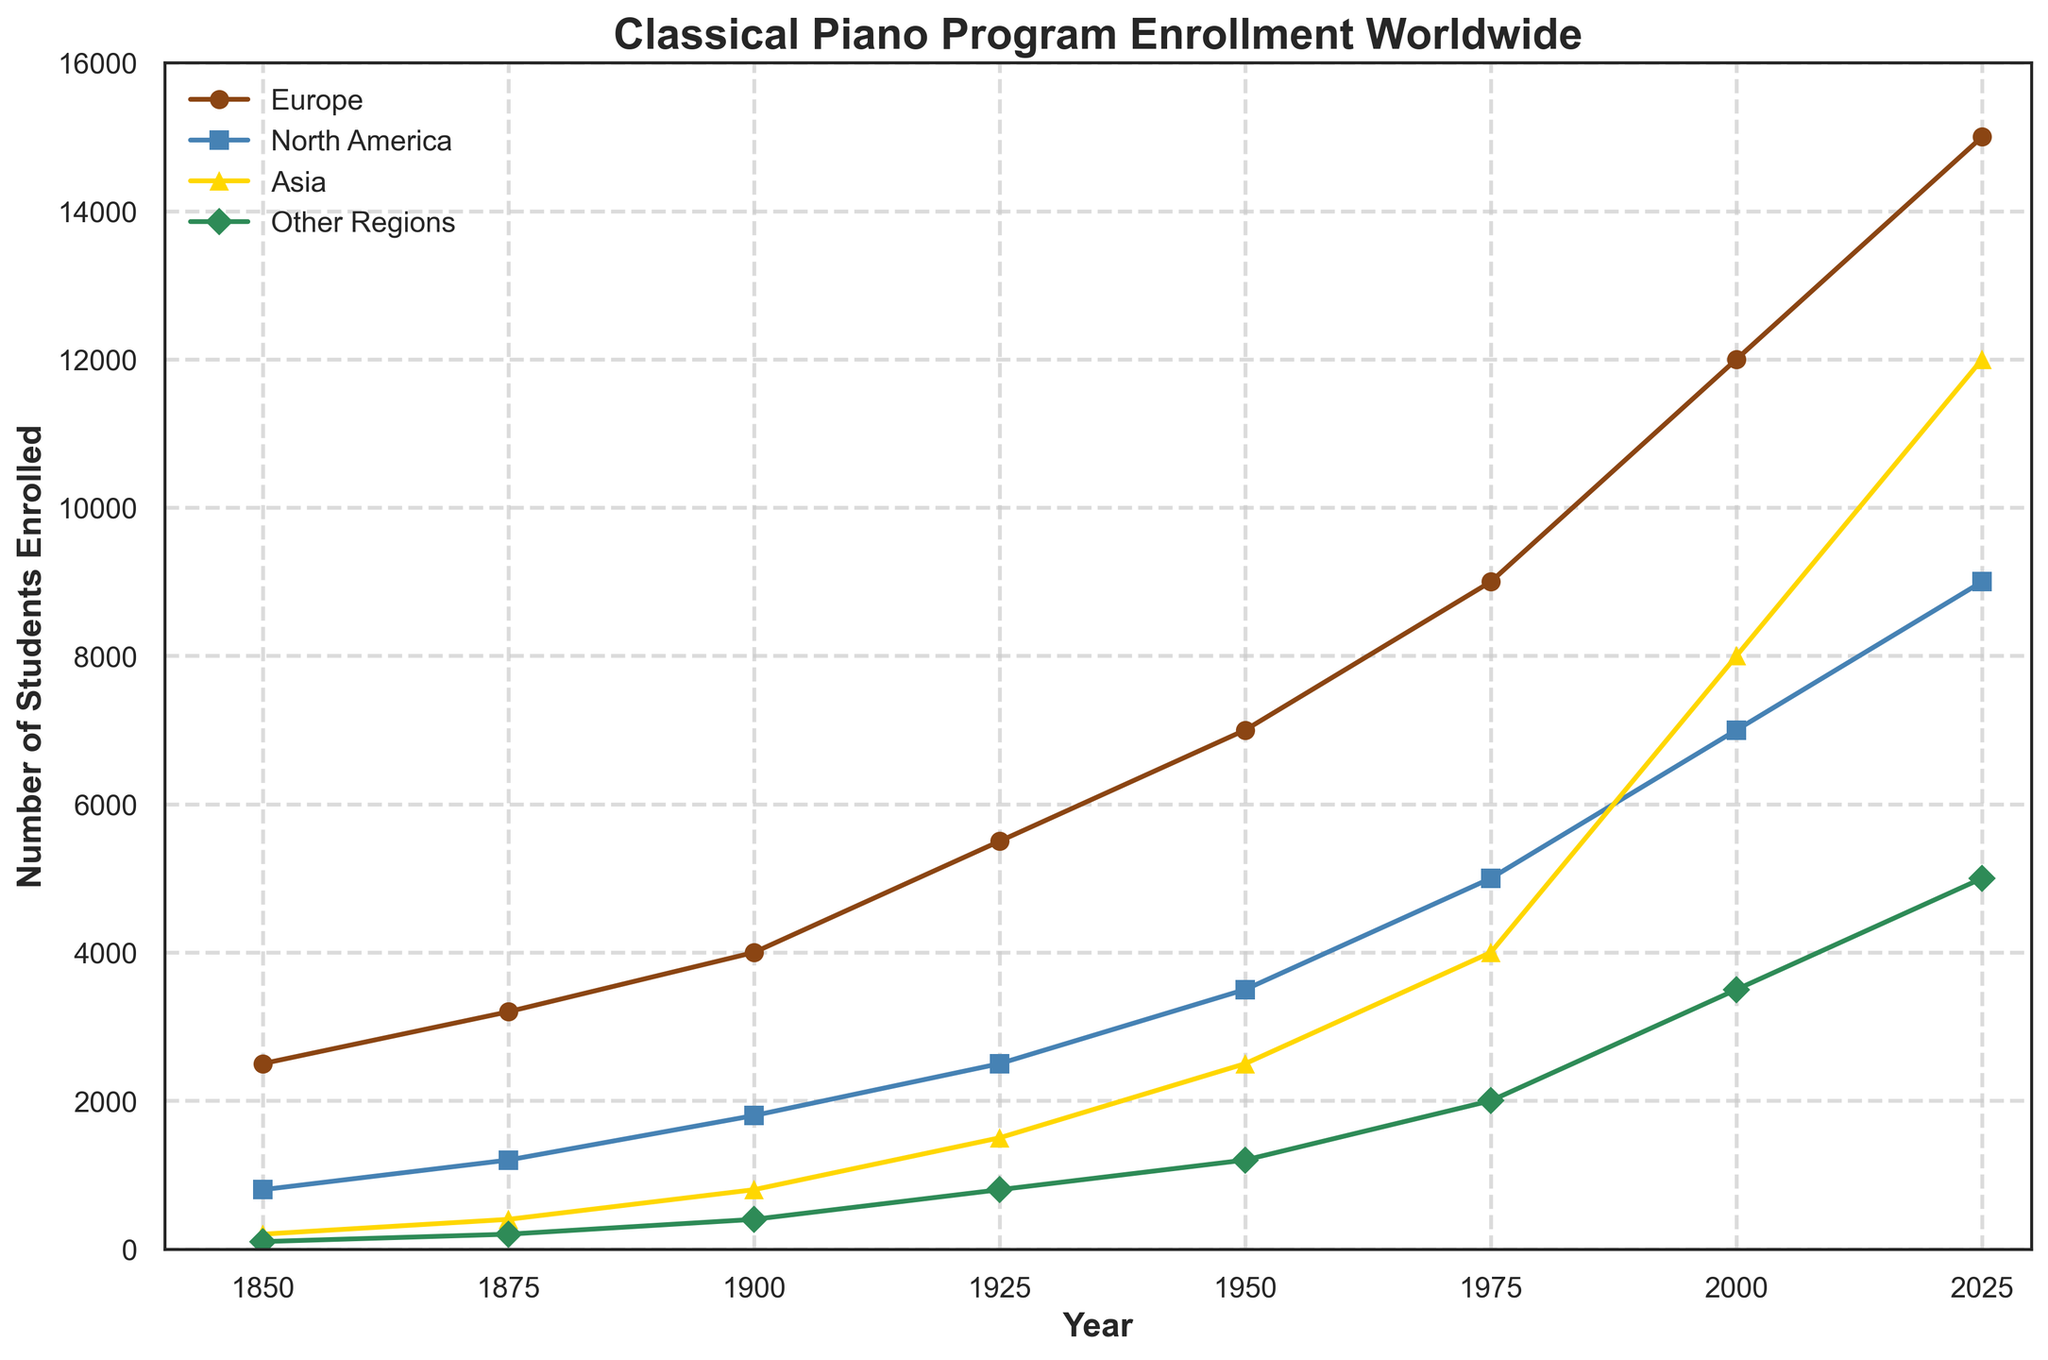How many students were enrolled in classical piano programs in Asia in 2000? Look at the data point on the line for Asia in the year 2000.
Answer: 8000 Which region had the highest increase in student enrollment from 1950 to 1975? Calculate the difference in enrollments for each region between 1950 and 1975: Europe (9000-7000), North America (5000-3500), Asia (4000-2500), Other Regions (2000-1200). The biggest increase is 2000 for Europe.
Answer: Europe By how much did the student enrollment in Europe surpass North America in 2025? Subtract the enrollment numbers in North America from Europe in 2025: 15000 - 9000.
Answer: 6000 Which region had the smallest total increase in enrollments from 1850 to 2025? Calculate the total increase for each region: Europe (15000-2500), North America (9000-800), Asia (12000-200), Other Regions (5000-100). The smallest increase is 4900 for Other Regions.
Answer: Other Regions During which period did North America see the most significant rise in enrollment? Compare the enrollment increases for North America across each period: 1850-1875 (1200-800), 1875-1900 (1800-1200), 1900-1925 (2500-1800), 1925-1950 (3500-2500), 1950-1975 (5000-3500), 1975-2000 (7000-5000), 2000-2025 (9000-7000). The biggest increase is 1000 from 1925-1950.
Answer: 1925-1950 In what year did Asia first surpass North America in student enrollments? Compare the enrollment numbers for Asia and North America in each year: In 1950 (2500 < 3500), In 1975 (4000 < 5000), In 2000 (8000 > 7000). So, Asia surpasses North America in 2000.
Answer: 2000 What is the combined enrollment for Europe and North America in 1900? Sum the enrollment numbers for Europe and North America in 1900: 4000 + 1800.
Answer: 5800 How did the total enrollment in Other Regions change between 1850 and 2025? Subtract the enrollment number in 1850 from that in 2025: 5000 - 100.
Answer: 4900 Which region had the highest total enrollment at any point, and in what year? Identify the maximum enrollment for each region and the corresponding year: Europe (15000 in 2025), North America (9000 in 2025), Asia (12000 in 2025), Other Regions (5000 in 2025). Europe had the highest in 2025.
Answer: Europe, 2025 What is the visual trend for student enrollments in classical piano programs in Asia from 1850 to 2025? Observe the general direction of the line representing Asia: the enrollments increase steadily, especially marked after 1950.
Answer: Increasing trend 